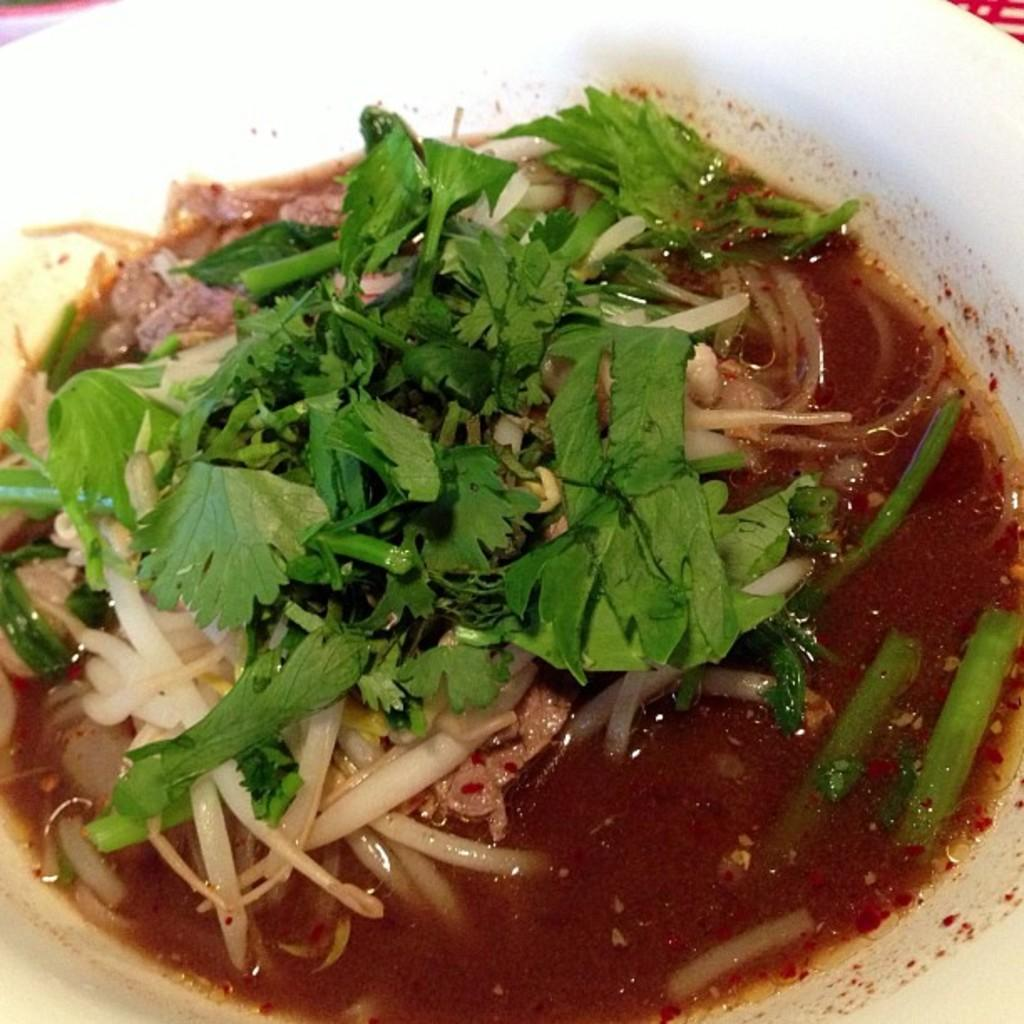What is placed in a bowl in the image? There is food placed in a bowl in the image. How many letters are visible in the image? There are no letters visible in the image; it only shows a bowl of food. How many sisters are present in the image? There are no people, including sisters, present in the image; it only shows a bowl of food. 